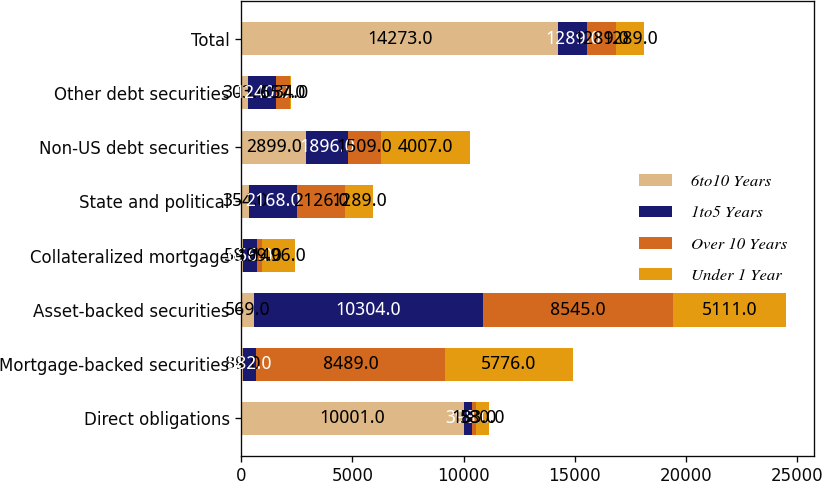Convert chart. <chart><loc_0><loc_0><loc_500><loc_500><stacked_bar_chart><ecel><fcel>Direct obligations<fcel>Mortgage-backed securities<fcel>Asset-backed securities<fcel>Collateralized mortgage<fcel>State and political<fcel>Non-US debt securities<fcel>Other debt securities<fcel>Total<nl><fcel>6to10 Years<fcel>10001<fcel>89<fcel>569<fcel>58<fcel>354<fcel>2899<fcel>303<fcel>14273<nl><fcel>1to5 Years<fcel>398<fcel>582<fcel>10304<fcel>656<fcel>2168<fcel>1896<fcel>1240<fcel>1289<nl><fcel>Over 10 Years<fcel>183<fcel>8489<fcel>8545<fcel>199<fcel>2126<fcel>1509<fcel>657<fcel>1289<nl><fcel>Under 1 Year<fcel>580<fcel>5776<fcel>5111<fcel>1496<fcel>1289<fcel>4007<fcel>34<fcel>1289<nl></chart> 